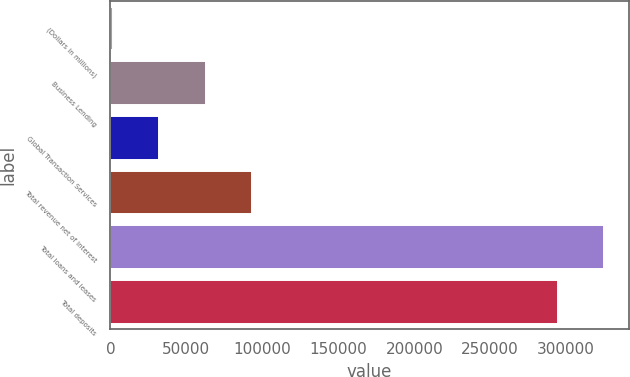Convert chart. <chart><loc_0><loc_0><loc_500><loc_500><bar_chart><fcel>(Dollars in millions)<fcel>Business Lending<fcel>Global Transaction Services<fcel>Total revenue net of interest<fcel>Total loans and leases<fcel>Total deposits<nl><fcel>2015<fcel>62640.6<fcel>32327.8<fcel>92953.4<fcel>325049<fcel>294736<nl></chart> 